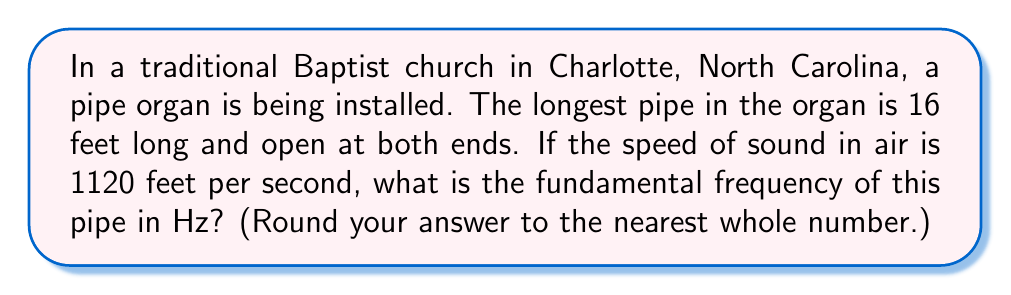Teach me how to tackle this problem. To solve this problem, we'll follow these steps:

1) First, recall the formula for the fundamental frequency of an open pipe:

   $$ f = \frac{v}{2L} $$

   Where:
   $f$ is the fundamental frequency in Hz
   $v$ is the speed of sound in feet per second
   $L$ is the length of the pipe in feet

2) We're given:
   $v = 1120$ feet/second
   $L = 16$ feet

3) Let's substitute these values into our equation:

   $$ f = \frac{1120}{2(16)} $$

4) Simplify:
   $$ f = \frac{1120}{32} = 35 $$

5) Therefore, the fundamental frequency is 35 Hz.

This frequency is quite low, which is characteristic of the deep, resonant tones produced by large church organs, reminiscent of traditional worship services.
Answer: 35 Hz 